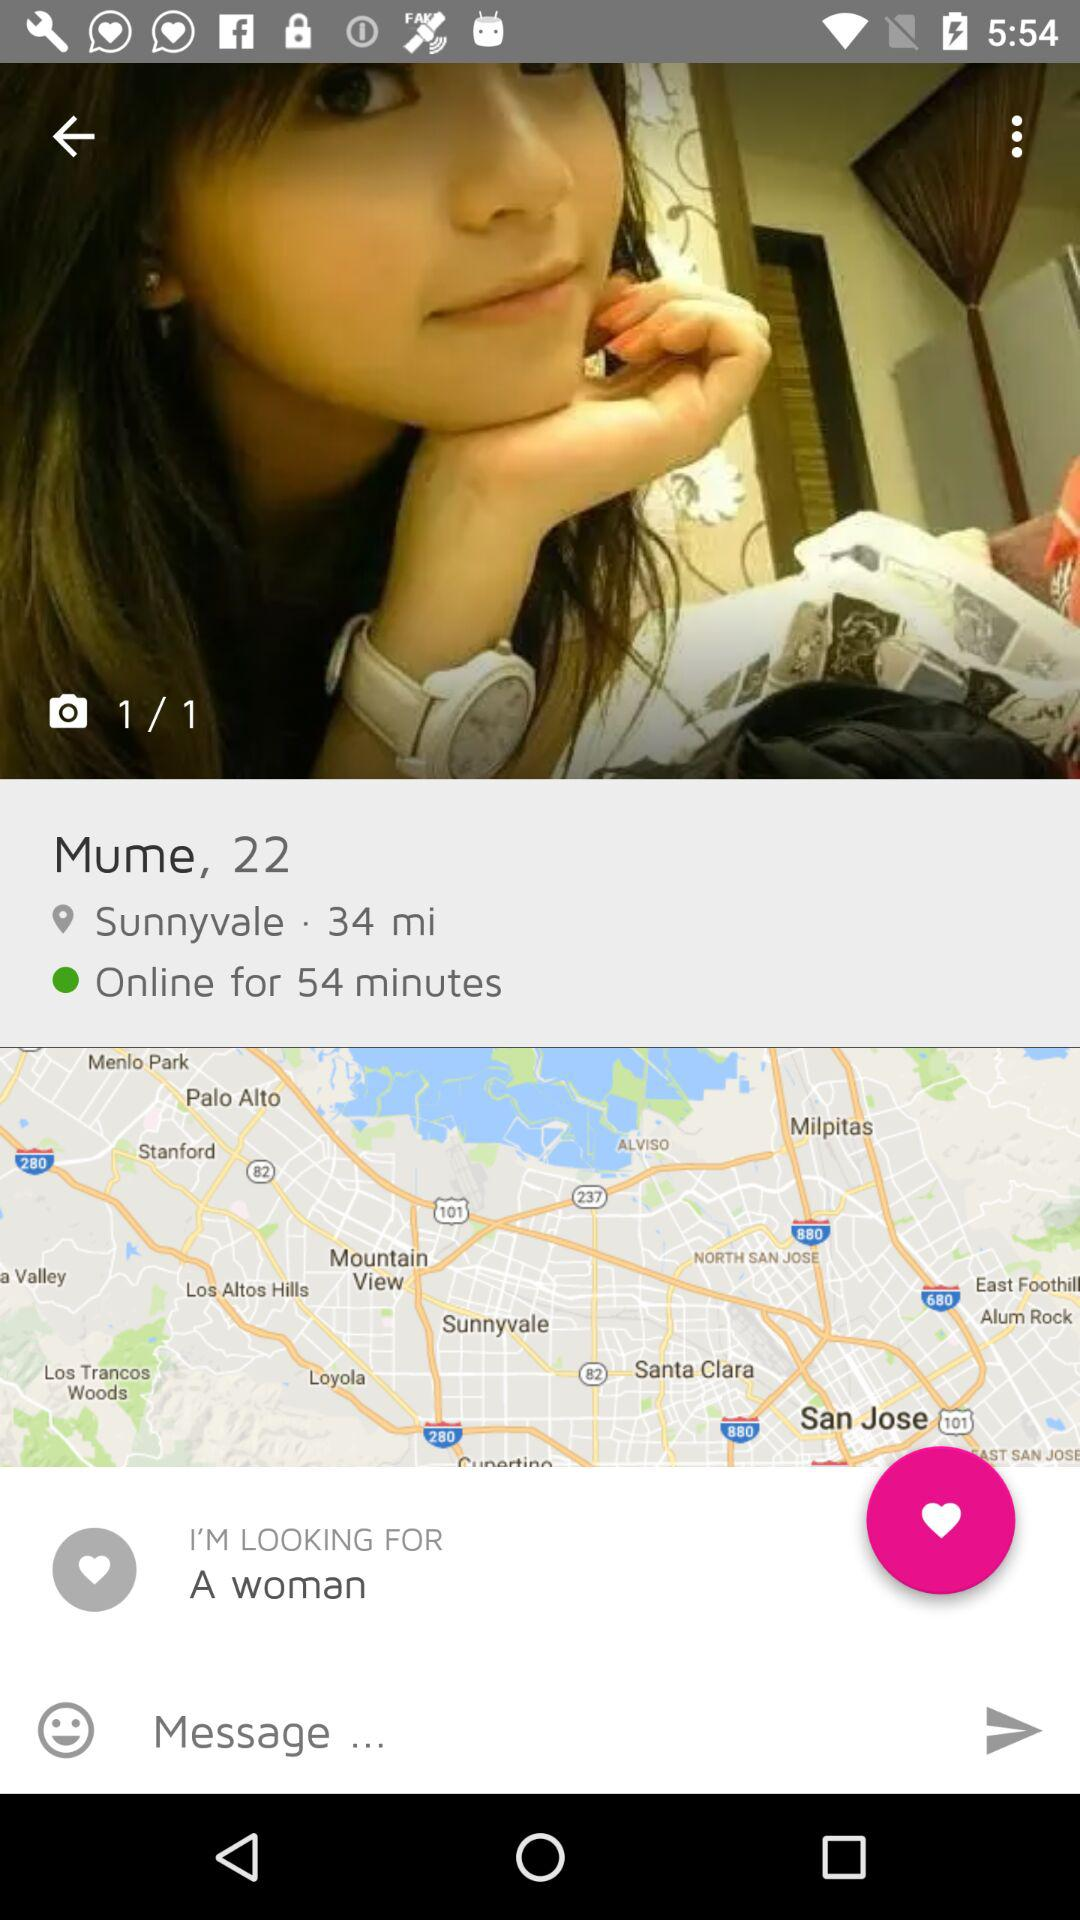How many images in total are there? There is 1 image in total. 